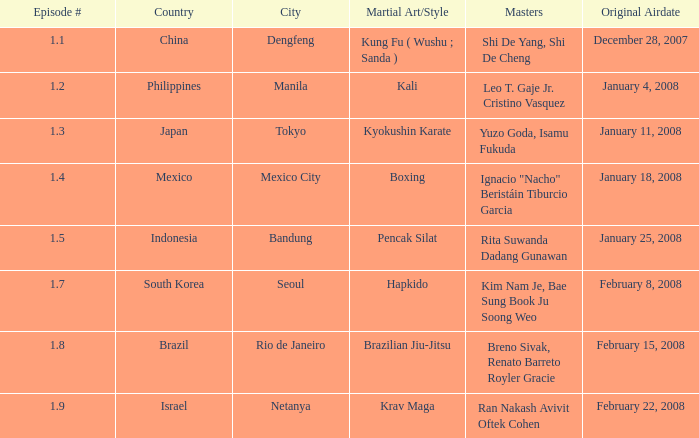When did the episode with a master employing brazilian jiu-jitsu premiere? February 15, 2008. 